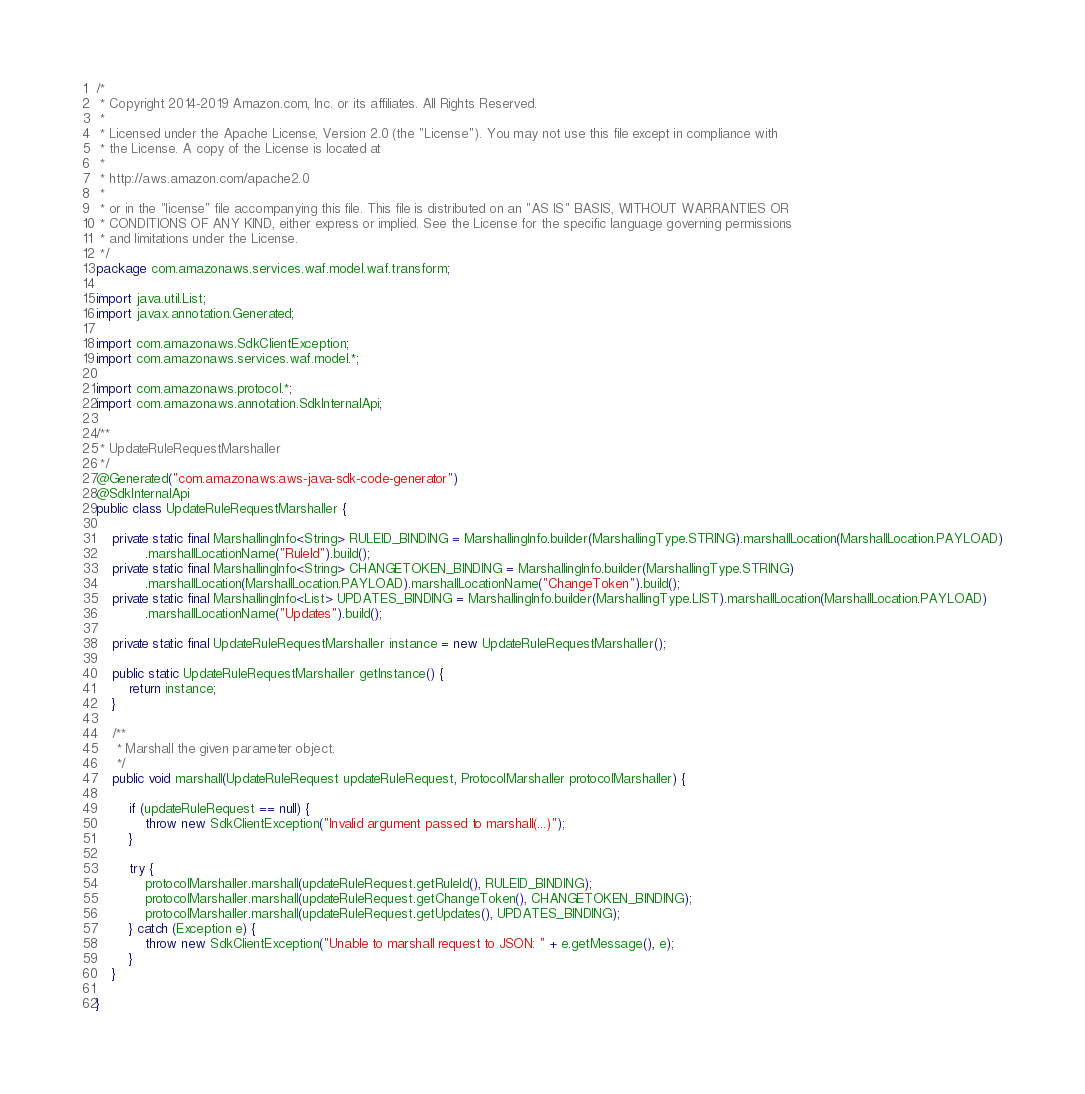<code> <loc_0><loc_0><loc_500><loc_500><_Java_>/*
 * Copyright 2014-2019 Amazon.com, Inc. or its affiliates. All Rights Reserved.
 * 
 * Licensed under the Apache License, Version 2.0 (the "License"). You may not use this file except in compliance with
 * the License. A copy of the License is located at
 * 
 * http://aws.amazon.com/apache2.0
 * 
 * or in the "license" file accompanying this file. This file is distributed on an "AS IS" BASIS, WITHOUT WARRANTIES OR
 * CONDITIONS OF ANY KIND, either express or implied. See the License for the specific language governing permissions
 * and limitations under the License.
 */
package com.amazonaws.services.waf.model.waf.transform;

import java.util.List;
import javax.annotation.Generated;

import com.amazonaws.SdkClientException;
import com.amazonaws.services.waf.model.*;

import com.amazonaws.protocol.*;
import com.amazonaws.annotation.SdkInternalApi;

/**
 * UpdateRuleRequestMarshaller
 */
@Generated("com.amazonaws:aws-java-sdk-code-generator")
@SdkInternalApi
public class UpdateRuleRequestMarshaller {

    private static final MarshallingInfo<String> RULEID_BINDING = MarshallingInfo.builder(MarshallingType.STRING).marshallLocation(MarshallLocation.PAYLOAD)
            .marshallLocationName("RuleId").build();
    private static final MarshallingInfo<String> CHANGETOKEN_BINDING = MarshallingInfo.builder(MarshallingType.STRING)
            .marshallLocation(MarshallLocation.PAYLOAD).marshallLocationName("ChangeToken").build();
    private static final MarshallingInfo<List> UPDATES_BINDING = MarshallingInfo.builder(MarshallingType.LIST).marshallLocation(MarshallLocation.PAYLOAD)
            .marshallLocationName("Updates").build();

    private static final UpdateRuleRequestMarshaller instance = new UpdateRuleRequestMarshaller();

    public static UpdateRuleRequestMarshaller getInstance() {
        return instance;
    }

    /**
     * Marshall the given parameter object.
     */
    public void marshall(UpdateRuleRequest updateRuleRequest, ProtocolMarshaller protocolMarshaller) {

        if (updateRuleRequest == null) {
            throw new SdkClientException("Invalid argument passed to marshall(...)");
        }

        try {
            protocolMarshaller.marshall(updateRuleRequest.getRuleId(), RULEID_BINDING);
            protocolMarshaller.marshall(updateRuleRequest.getChangeToken(), CHANGETOKEN_BINDING);
            protocolMarshaller.marshall(updateRuleRequest.getUpdates(), UPDATES_BINDING);
        } catch (Exception e) {
            throw new SdkClientException("Unable to marshall request to JSON: " + e.getMessage(), e);
        }
    }

}
</code> 